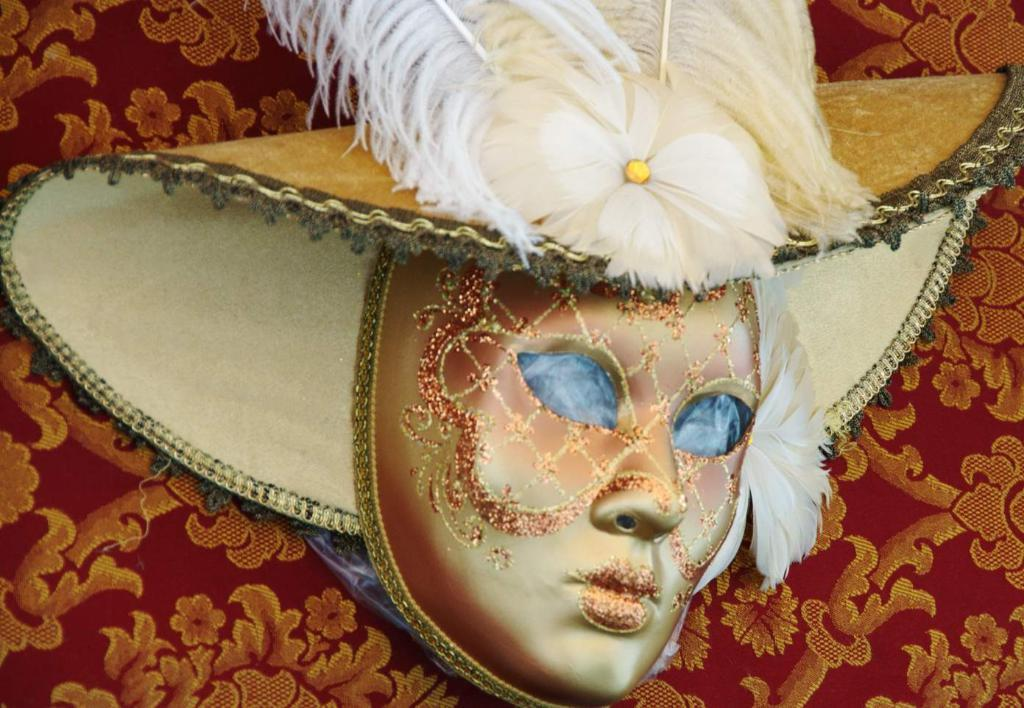What object is the main focus of the image? There is a mask in the image. What is located behind the mask in the image? There is a cloth behind the mask in the image. What type of plants can be seen growing inside the church in the image? There is no church or plants present in the image; it only features a mask and a cloth. 